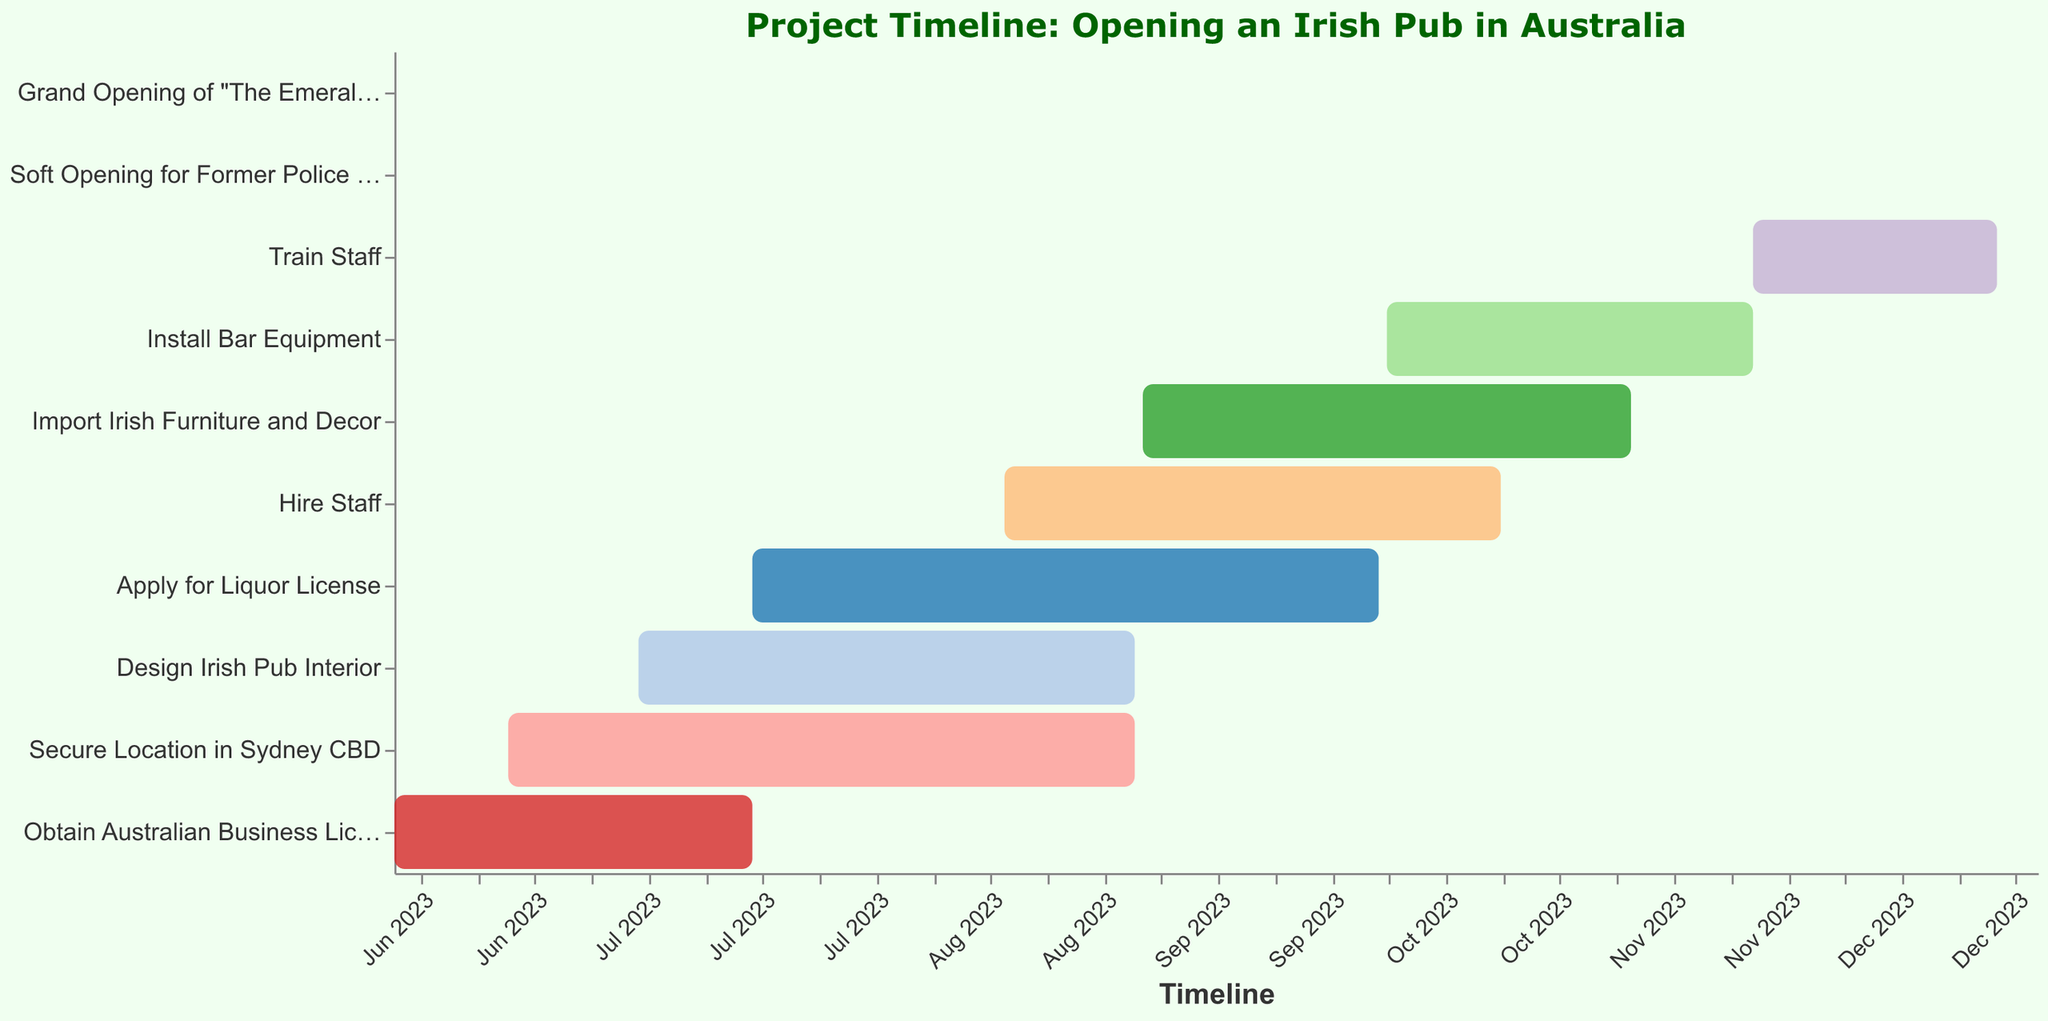What is the duration of the task "Secure Location in Sydney CBD"? The task "Secure Location in Sydney CBD" has its duration listed as 77 days in the data table.
Answer: 77 days How many tasks start in October 2023? By examining the start dates in the visualized data, the tasks that start in October 2023 are "Install Bar Equipment" and "Train Staff". There are 2 tasks.
Answer: 2 When does the task "Hire Staff" finish? Looking at the data, the task "Hire Staff" ends on 2023-10-15.
Answer: 2023-10-15 Which task has the shortest duration and how long is it? By comparing the durations of all tasks, the shortest duration is for the "Soft Opening for Former Police Colleagues," which lasts 1 day.
Answer: Soft Opening for Former Police Colleagues, 1 day Which task overlaps with the "Apply for Liquor License" in terms of timeline? "Apply for Liquor License" runs from 2023-07-15 to 2023-09-30. Tasks overlapping with this period are "Secure Location in Sydney CBD," "Design Irish Pub Interior," "Hire Staff," and "Import Irish Furniture and Decor".
Answer: Secure Location in Sydney CBD, Design Irish Pub Interior, Hire Staff, Import Irish Furniture and Decor What is the total duration for all tasks combined? Summing up the durations from the data: 45 + 77 + 61 + 77 + 61 + 60 + 45 + 30 + 1 + 1 = 458 days.
Answer: 458 days Which tasks are scheduled to be completed in December 2023? The tasks that are set to be completed in December 2023 are "Train Staff" (ends 2023-12-15), the "Soft Opening for Former Police Colleagues" (2023-12-16), and the "Grand Opening of 'The Emerald Shamrock'" (2023-12-20).
Answer: Train Staff, Soft Opening for Former Police Colleagues, Grand Opening of 'The Emerald Shamrock' When does the task "Import Irish Furniture and Decor" overlap with "Install Bar Equipment"? The task "Import Irish Furniture and Decor" runs from 2023-09-01 to 2023-10-31, and "Install Bar Equipment" runs from 2023-10-01 to 2023-11-15. The overlapping period is from 2023-10-01 to 2023-10-31.
Answer: 2023-10-01 to 2023-10-31 What is the longest duration task? By comparing the durations, both the tasks "Secure Location in Sydney CBD" and "Apply for Liquor License" have the longest duration of 77 days.
Answer: Secure Location in Sydney CBD, Apply for Liquor License, 77 days 